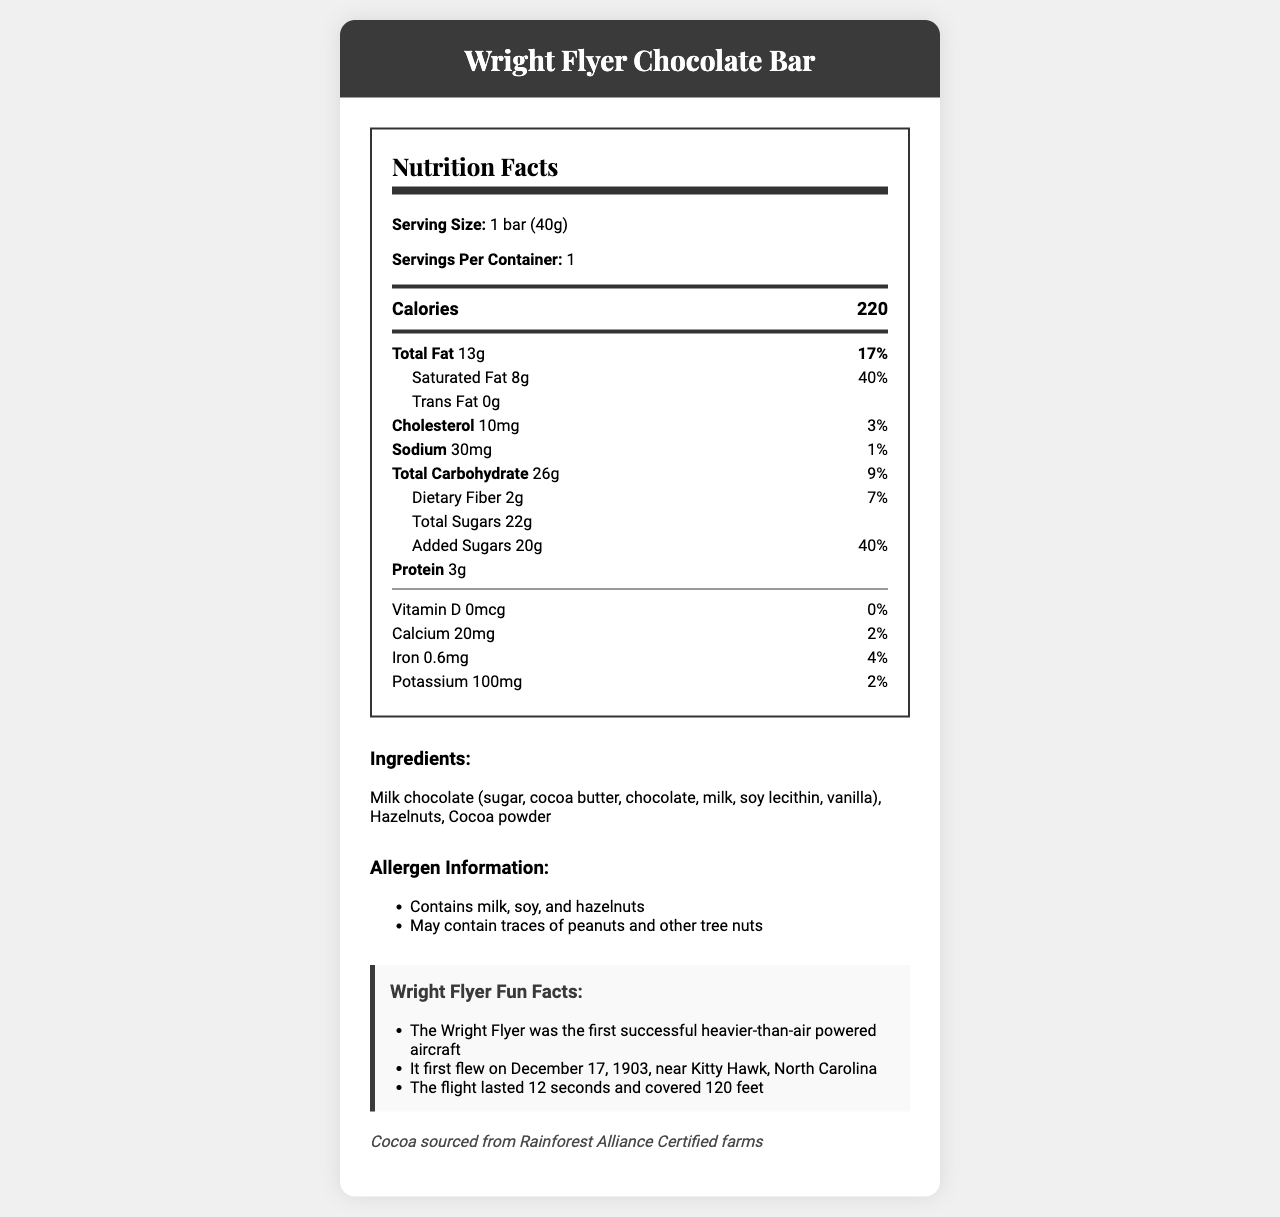what is the serving size of the Wright Flyer Chocolate Bar? The serving size is clearly stated as "1 bar (40g)" in the Nutrition Facts.
Answer: 1 bar (40g) how many calories are there in one Wright Flyer Chocolate Bar? The document specifies that there are 220 calories in one bar.
Answer: 220 what is the daily value percentage of saturated fat in the chocolate bar? The daily value for saturated fat is indicated as 40% in the Nutrition Facts section.
Answer: 40% what allergens are present in the Wright Flyer Chocolate Bar? The allergens section states the presence of milk, soy, and hazelnuts, and mentions possible traces of peanuts and other tree nuts.
Answer: Contains milk, soy, and hazelnuts; may contain traces of peanuts and other tree nuts how much added sugar does the Wright Flyer Chocolate Bar contain? The Nutrition Facts label lists added sugars as 20g.
Answer: 20g which company manufactures the Wright Flyer Chocolate Bar? The manufacturer is listed as AviationSweets Inc.
Answer: AviationSweets Inc. what materials are used to illustrate the wrapper of the Wright Flyer Chocolate Bar? A. A photograph B. A painting C. A detailed illustration The packaging information mentions a "detailed illustration of the Wright Flyer."
Answer: C what is the weight of the bar of the Wright Flyer Chocolate Bar? A. 35g B. 40g C. 50g The serving size is listed as "1 bar (40g)," making it clear that the bar weighs 40g.
Answer: B does the Wright Flyer Chocolate Bar contain any dietary fiber? The Nutrition Facts lists dietary fiber as 2g, so it does contain dietary fiber.
Answer: Yes is the Wright Flyer Chocolate Bar free from trans fat? The Nutrition Facts clearly state that the trans fat content is 0g.
Answer: Yes summarize the main ideas of the document. The document comprehensively lists nutritional information, ingredients, allergen warnings, fun facts about the Wright Flyer, and sustainability notes together with the packaging description.
Answer: The document provides nutrition facts and ingredient details of the Wright Flyer Chocolate Bar, including caloric content and daily values of various nutrients. It warns about allergens and includes fun facts about the Wright Flyer aircraft, manufactured by AviationSweets Inc. The packaging features an illustration of the Wright Flyer, and the cocoa is sourced from sustainable farms. how much protein is in the Wright Flyer Chocolate Bar? The Nutrition Facts lists the protein content as 3g.
Answer: 3g what is the source of the cocoa used in the Wright Flyer Chocolate Bar? The sustainability note specifies that the cocoa is sourced from Rainforest Alliance Certified farms.
Answer: Rainforest Alliance Certified farms how many servings are in one container of the Wright Flyer Chocolate Bar? The document mentions that there is 1 serving per container.
Answer: 1 how much calcium does the Wright Flyer Chocolate Bar provide? The Nutrition Facts show that the chocolate bar provides 20mg of calcium, which is 2% of the daily value.
Answer: 20mg (2% DV) when did the Wright Flyer first fly? One of the fun facts lists the date of the Wright Flyer's first flight as December 17, 1903.
Answer: December 17, 1903 how many grams of total sugars are in the Wright Flyer Chocolate Bar? The total sugars amount is listed as 22g on the Nutrition Facts label.
Answer: 22g is there any cholesterol in the Wright Flyer Chocolate Bar? The Nutrition Facts section indicates the chocolate bar contains 10mg of cholesterol.
Answer: Yes which famous aircraft is illustrated on the wrapper of the chocolate bar? The packaging information specifies that the wrapper features an illustration of the Wright Flyer.
Answer: The Wright Flyer who were the first people to fly the Wright Flyer? The document does not provide information on the individuals who flew the Wright Flyer.
Answer: Not enough information 